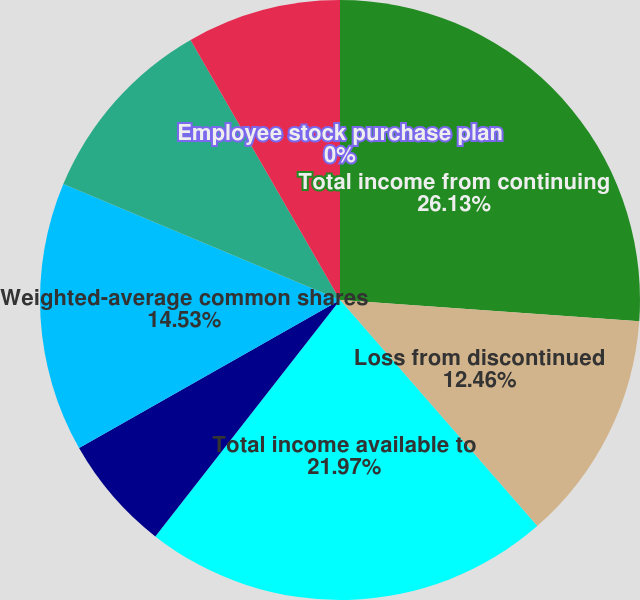Convert chart to OTSL. <chart><loc_0><loc_0><loc_500><loc_500><pie_chart><fcel>Total income from continuing<fcel>Loss from discontinued<fcel>Total income available to<fcel>Undistributed earnings for<fcel>Weighted-average common shares<fcel>Restricted stock units<fcel>Stock options<fcel>Employee stock purchase plan<nl><fcel>26.12%<fcel>12.46%<fcel>21.97%<fcel>6.23%<fcel>14.53%<fcel>10.38%<fcel>8.3%<fcel>0.0%<nl></chart> 